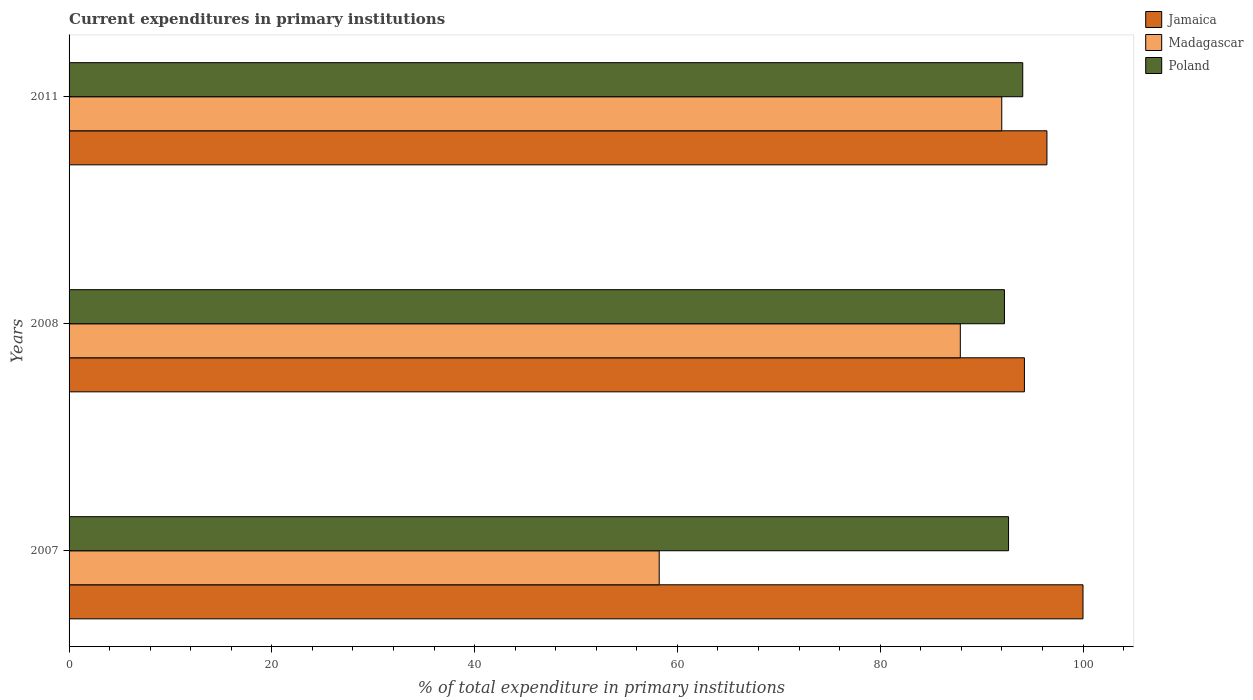How many different coloured bars are there?
Offer a very short reply. 3. Are the number of bars per tick equal to the number of legend labels?
Offer a very short reply. Yes. Are the number of bars on each tick of the Y-axis equal?
Ensure brevity in your answer.  Yes. How many bars are there on the 3rd tick from the bottom?
Offer a very short reply. 3. In how many cases, is the number of bars for a given year not equal to the number of legend labels?
Provide a succinct answer. 0. What is the current expenditures in primary institutions in Jamaica in 2008?
Keep it short and to the point. 94.22. Across all years, what is the maximum current expenditures in primary institutions in Madagascar?
Provide a short and direct response. 91.99. Across all years, what is the minimum current expenditures in primary institutions in Poland?
Give a very brief answer. 92.25. In which year was the current expenditures in primary institutions in Jamaica maximum?
Your answer should be very brief. 2007. What is the total current expenditures in primary institutions in Poland in the graph?
Offer a terse response. 278.97. What is the difference between the current expenditures in primary institutions in Jamaica in 2007 and that in 2008?
Your response must be concise. 5.78. What is the difference between the current expenditures in primary institutions in Jamaica in 2011 and the current expenditures in primary institutions in Poland in 2007?
Your answer should be very brief. 3.79. What is the average current expenditures in primary institutions in Jamaica per year?
Your response must be concise. 96.89. In the year 2008, what is the difference between the current expenditures in primary institutions in Jamaica and current expenditures in primary institutions in Poland?
Give a very brief answer. 1.97. What is the ratio of the current expenditures in primary institutions in Madagascar in 2007 to that in 2011?
Give a very brief answer. 0.63. Is the current expenditures in primary institutions in Poland in 2007 less than that in 2008?
Your response must be concise. No. What is the difference between the highest and the second highest current expenditures in primary institutions in Poland?
Give a very brief answer. 1.4. What is the difference between the highest and the lowest current expenditures in primary institutions in Jamaica?
Give a very brief answer. 5.78. In how many years, is the current expenditures in primary institutions in Jamaica greater than the average current expenditures in primary institutions in Jamaica taken over all years?
Provide a short and direct response. 1. Is the sum of the current expenditures in primary institutions in Jamaica in 2008 and 2011 greater than the maximum current expenditures in primary institutions in Madagascar across all years?
Your answer should be compact. Yes. What does the 3rd bar from the top in 2008 represents?
Give a very brief answer. Jamaica. What does the 3rd bar from the bottom in 2008 represents?
Keep it short and to the point. Poland. How many bars are there?
Provide a succinct answer. 9. Are all the bars in the graph horizontal?
Provide a short and direct response. Yes. How many years are there in the graph?
Your answer should be compact. 3. Are the values on the major ticks of X-axis written in scientific E-notation?
Make the answer very short. No. Does the graph contain any zero values?
Your answer should be compact. No. How many legend labels are there?
Your answer should be compact. 3. What is the title of the graph?
Make the answer very short. Current expenditures in primary institutions. Does "Cyprus" appear as one of the legend labels in the graph?
Your answer should be very brief. No. What is the label or title of the X-axis?
Offer a very short reply. % of total expenditure in primary institutions. What is the label or title of the Y-axis?
Offer a terse response. Years. What is the % of total expenditure in primary institutions in Madagascar in 2007?
Offer a very short reply. 58.2. What is the % of total expenditure in primary institutions in Poland in 2007?
Make the answer very short. 92.66. What is the % of total expenditure in primary institutions of Jamaica in 2008?
Provide a short and direct response. 94.22. What is the % of total expenditure in primary institutions in Madagascar in 2008?
Offer a very short reply. 87.9. What is the % of total expenditure in primary institutions in Poland in 2008?
Keep it short and to the point. 92.25. What is the % of total expenditure in primary institutions of Jamaica in 2011?
Offer a terse response. 96.44. What is the % of total expenditure in primary institutions of Madagascar in 2011?
Give a very brief answer. 91.99. What is the % of total expenditure in primary institutions in Poland in 2011?
Offer a terse response. 94.06. Across all years, what is the maximum % of total expenditure in primary institutions in Jamaica?
Your answer should be compact. 100. Across all years, what is the maximum % of total expenditure in primary institutions in Madagascar?
Offer a very short reply. 91.99. Across all years, what is the maximum % of total expenditure in primary institutions of Poland?
Provide a succinct answer. 94.06. Across all years, what is the minimum % of total expenditure in primary institutions in Jamaica?
Make the answer very short. 94.22. Across all years, what is the minimum % of total expenditure in primary institutions in Madagascar?
Give a very brief answer. 58.2. Across all years, what is the minimum % of total expenditure in primary institutions of Poland?
Offer a very short reply. 92.25. What is the total % of total expenditure in primary institutions in Jamaica in the graph?
Make the answer very short. 290.67. What is the total % of total expenditure in primary institutions of Madagascar in the graph?
Your answer should be compact. 238.09. What is the total % of total expenditure in primary institutions in Poland in the graph?
Your answer should be very brief. 278.97. What is the difference between the % of total expenditure in primary institutions in Jamaica in 2007 and that in 2008?
Provide a short and direct response. 5.78. What is the difference between the % of total expenditure in primary institutions of Madagascar in 2007 and that in 2008?
Provide a short and direct response. -29.7. What is the difference between the % of total expenditure in primary institutions in Poland in 2007 and that in 2008?
Offer a terse response. 0.4. What is the difference between the % of total expenditure in primary institutions in Jamaica in 2007 and that in 2011?
Ensure brevity in your answer.  3.56. What is the difference between the % of total expenditure in primary institutions of Madagascar in 2007 and that in 2011?
Provide a succinct answer. -33.79. What is the difference between the % of total expenditure in primary institutions of Poland in 2007 and that in 2011?
Your answer should be very brief. -1.4. What is the difference between the % of total expenditure in primary institutions of Jamaica in 2008 and that in 2011?
Offer a terse response. -2.22. What is the difference between the % of total expenditure in primary institutions of Madagascar in 2008 and that in 2011?
Your response must be concise. -4.09. What is the difference between the % of total expenditure in primary institutions in Poland in 2008 and that in 2011?
Your answer should be very brief. -1.8. What is the difference between the % of total expenditure in primary institutions of Jamaica in 2007 and the % of total expenditure in primary institutions of Madagascar in 2008?
Provide a short and direct response. 12.1. What is the difference between the % of total expenditure in primary institutions in Jamaica in 2007 and the % of total expenditure in primary institutions in Poland in 2008?
Ensure brevity in your answer.  7.75. What is the difference between the % of total expenditure in primary institutions in Madagascar in 2007 and the % of total expenditure in primary institutions in Poland in 2008?
Your answer should be very brief. -34.05. What is the difference between the % of total expenditure in primary institutions in Jamaica in 2007 and the % of total expenditure in primary institutions in Madagascar in 2011?
Make the answer very short. 8.01. What is the difference between the % of total expenditure in primary institutions of Jamaica in 2007 and the % of total expenditure in primary institutions of Poland in 2011?
Make the answer very short. 5.94. What is the difference between the % of total expenditure in primary institutions of Madagascar in 2007 and the % of total expenditure in primary institutions of Poland in 2011?
Your answer should be very brief. -35.85. What is the difference between the % of total expenditure in primary institutions in Jamaica in 2008 and the % of total expenditure in primary institutions in Madagascar in 2011?
Your answer should be very brief. 2.23. What is the difference between the % of total expenditure in primary institutions of Jamaica in 2008 and the % of total expenditure in primary institutions of Poland in 2011?
Your response must be concise. 0.17. What is the difference between the % of total expenditure in primary institutions of Madagascar in 2008 and the % of total expenditure in primary institutions of Poland in 2011?
Your response must be concise. -6.16. What is the average % of total expenditure in primary institutions of Jamaica per year?
Offer a terse response. 96.89. What is the average % of total expenditure in primary institutions in Madagascar per year?
Give a very brief answer. 79.36. What is the average % of total expenditure in primary institutions of Poland per year?
Offer a very short reply. 92.99. In the year 2007, what is the difference between the % of total expenditure in primary institutions of Jamaica and % of total expenditure in primary institutions of Madagascar?
Offer a terse response. 41.8. In the year 2007, what is the difference between the % of total expenditure in primary institutions of Jamaica and % of total expenditure in primary institutions of Poland?
Offer a terse response. 7.34. In the year 2007, what is the difference between the % of total expenditure in primary institutions in Madagascar and % of total expenditure in primary institutions in Poland?
Offer a very short reply. -34.45. In the year 2008, what is the difference between the % of total expenditure in primary institutions of Jamaica and % of total expenditure in primary institutions of Madagascar?
Provide a short and direct response. 6.32. In the year 2008, what is the difference between the % of total expenditure in primary institutions in Jamaica and % of total expenditure in primary institutions in Poland?
Keep it short and to the point. 1.97. In the year 2008, what is the difference between the % of total expenditure in primary institutions in Madagascar and % of total expenditure in primary institutions in Poland?
Keep it short and to the point. -4.35. In the year 2011, what is the difference between the % of total expenditure in primary institutions of Jamaica and % of total expenditure in primary institutions of Madagascar?
Offer a terse response. 4.45. In the year 2011, what is the difference between the % of total expenditure in primary institutions in Jamaica and % of total expenditure in primary institutions in Poland?
Offer a very short reply. 2.39. In the year 2011, what is the difference between the % of total expenditure in primary institutions in Madagascar and % of total expenditure in primary institutions in Poland?
Keep it short and to the point. -2.07. What is the ratio of the % of total expenditure in primary institutions in Jamaica in 2007 to that in 2008?
Offer a very short reply. 1.06. What is the ratio of the % of total expenditure in primary institutions of Madagascar in 2007 to that in 2008?
Your answer should be compact. 0.66. What is the ratio of the % of total expenditure in primary institutions of Jamaica in 2007 to that in 2011?
Offer a very short reply. 1.04. What is the ratio of the % of total expenditure in primary institutions of Madagascar in 2007 to that in 2011?
Offer a very short reply. 0.63. What is the ratio of the % of total expenditure in primary institutions of Poland in 2007 to that in 2011?
Your answer should be very brief. 0.99. What is the ratio of the % of total expenditure in primary institutions in Madagascar in 2008 to that in 2011?
Ensure brevity in your answer.  0.96. What is the ratio of the % of total expenditure in primary institutions in Poland in 2008 to that in 2011?
Give a very brief answer. 0.98. What is the difference between the highest and the second highest % of total expenditure in primary institutions in Jamaica?
Ensure brevity in your answer.  3.56. What is the difference between the highest and the second highest % of total expenditure in primary institutions of Madagascar?
Ensure brevity in your answer.  4.09. What is the difference between the highest and the second highest % of total expenditure in primary institutions in Poland?
Provide a succinct answer. 1.4. What is the difference between the highest and the lowest % of total expenditure in primary institutions in Jamaica?
Offer a terse response. 5.78. What is the difference between the highest and the lowest % of total expenditure in primary institutions of Madagascar?
Your answer should be compact. 33.79. What is the difference between the highest and the lowest % of total expenditure in primary institutions in Poland?
Your answer should be compact. 1.8. 